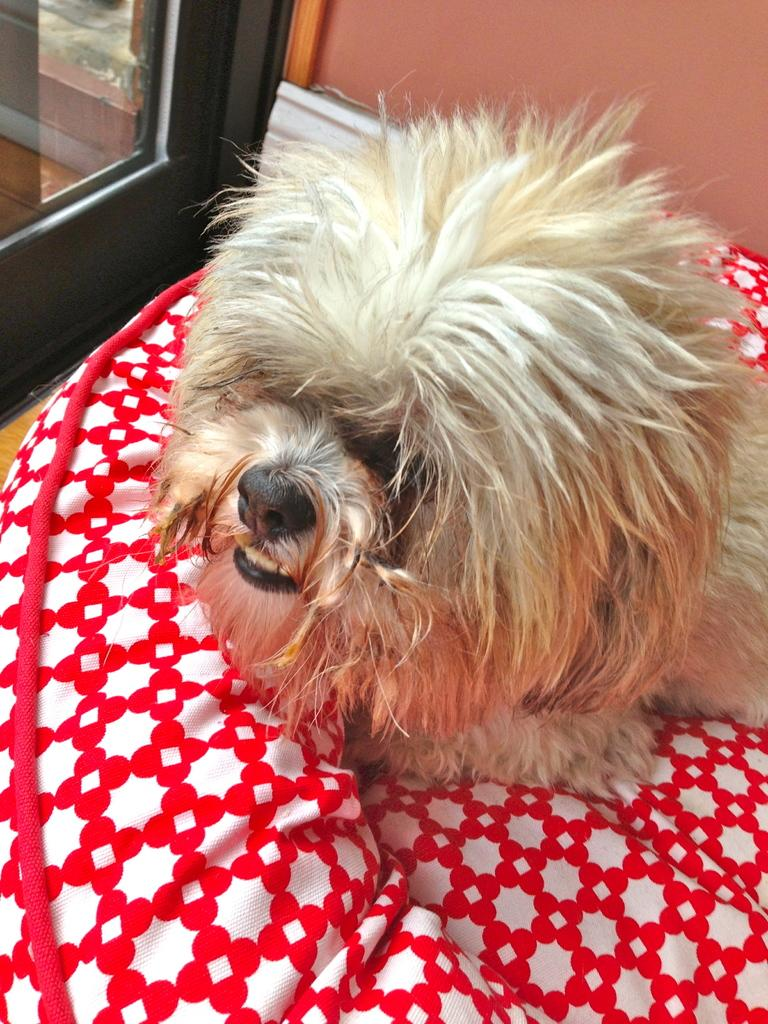What type of furniture is present in the image? There is a bed in the image. What is placed on the bed? There is a day on the bed. Can you describe any architectural features in the image? There is a possible door or window in the top left corner of the image, and a wall is visible at the top of the image. What language is the day speaking in the image? There is no indication that the day is speaking in the image, nor is there any information about the language it might be speaking if it were. 